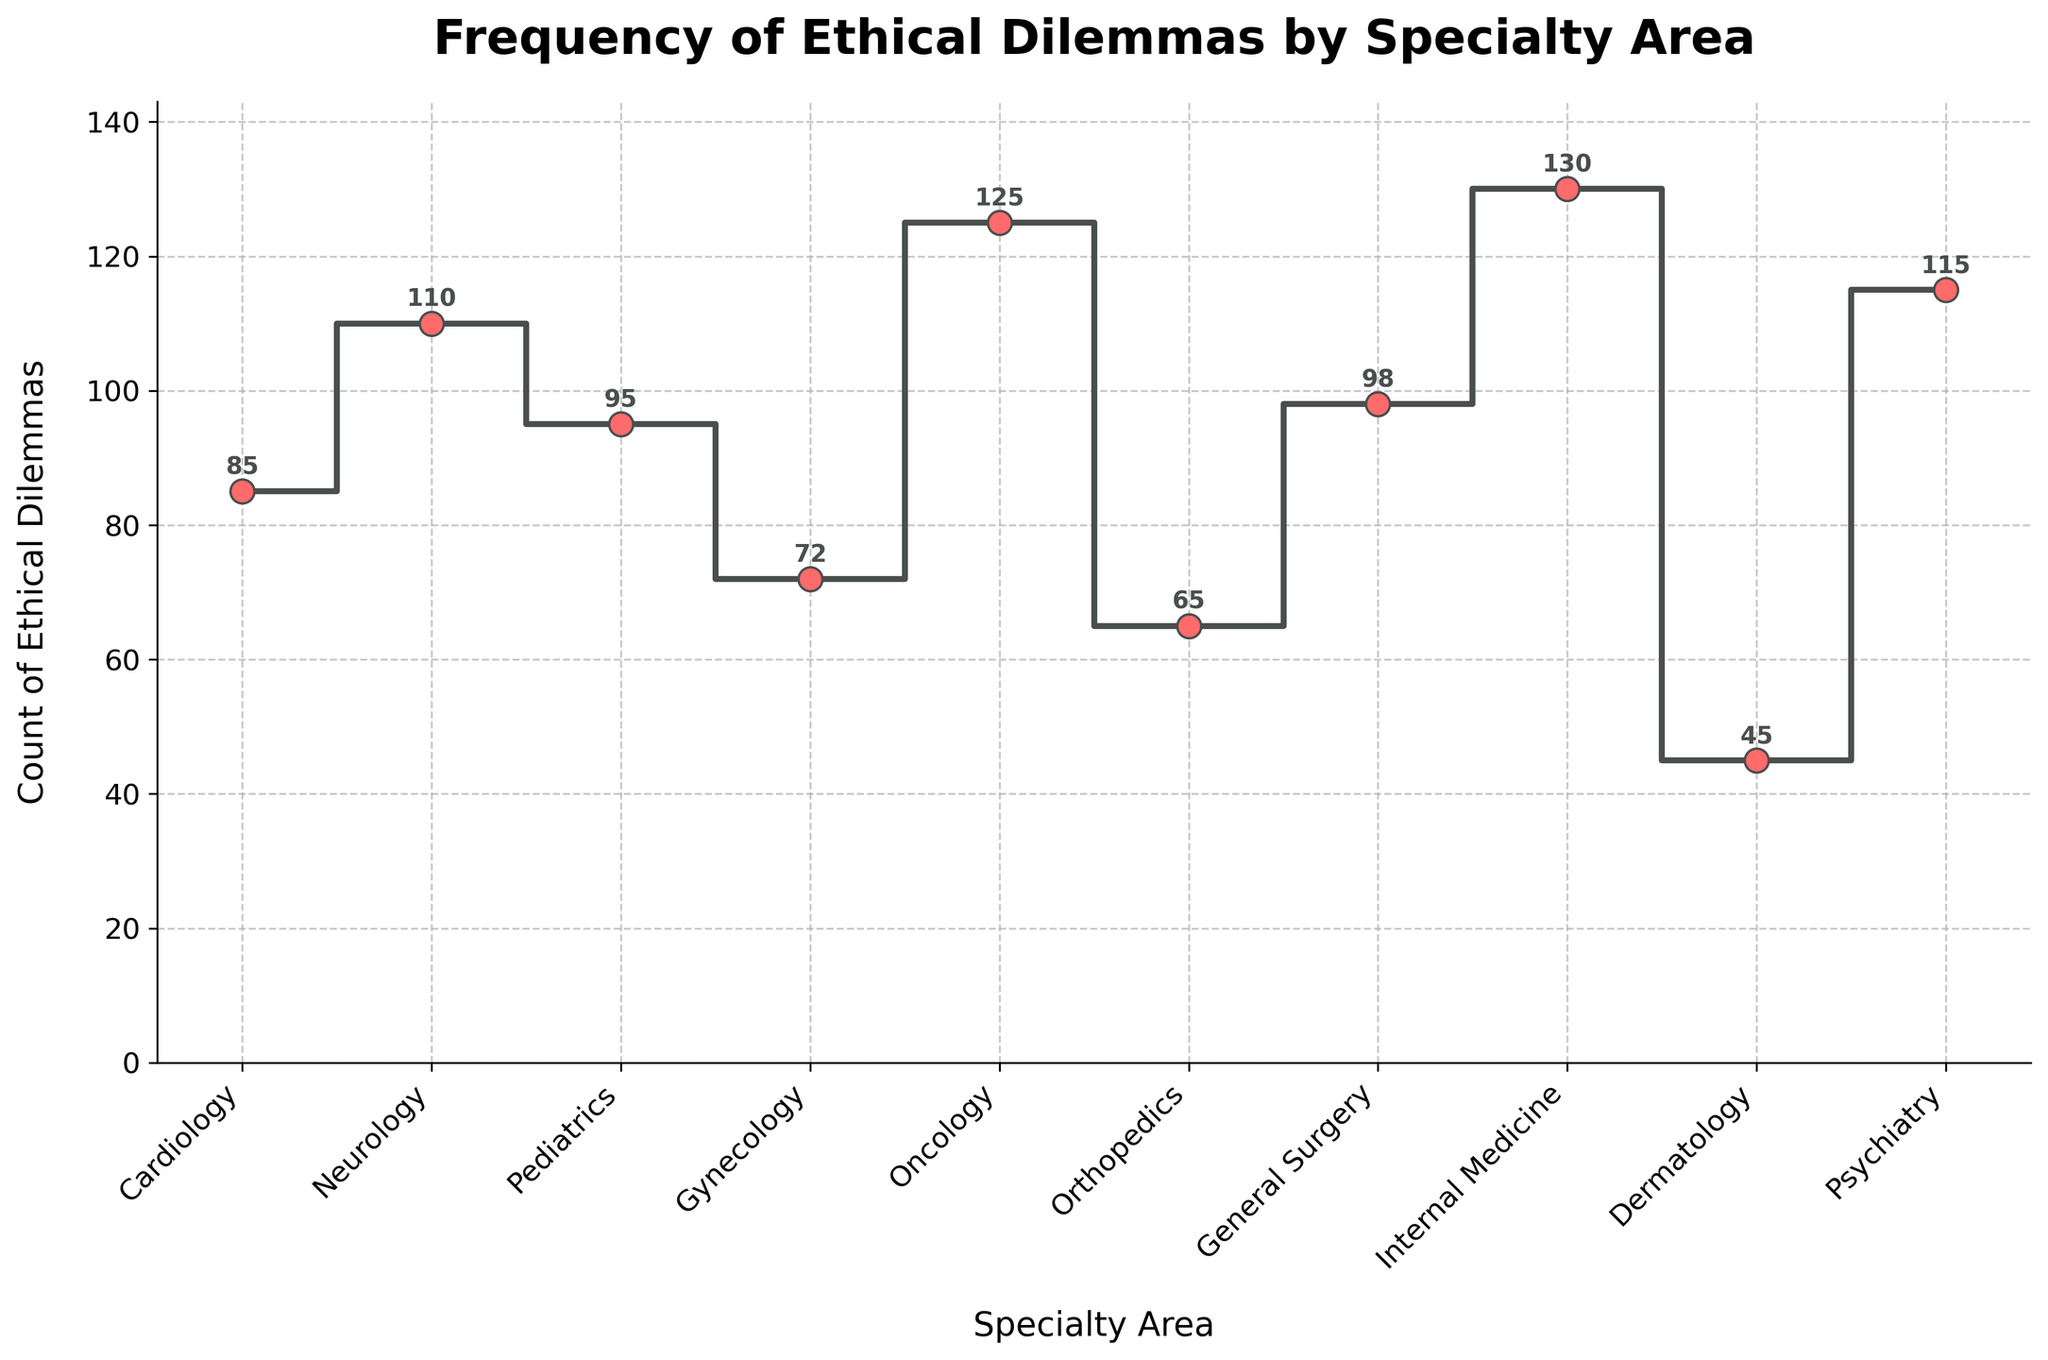What is the title of the plot? The title is usually positioned at the top of the plot and provides a brief description of what the plot represents. In this case, it says: 'Frequency of Ethical Dilemmas by Specialty Area'
Answer: Frequency of Ethical Dilemmas by Specialty Area Which specialty has the highest count of ethical dilemmas? To find the highest count, look for the tallest step in the plot. The plot shows Oncology with the highest step at 125 dilemmas.
Answer: Oncology What is the range of the counts of ethical dilemmas across all specialties? The range is the difference between the highest and lowest counts. The highest is Oncology with 125, and the lowest is Dermatology with 45. Therefore, the range is 125 - 45 = 80.
Answer: 80 How does the count of ethical dilemmas in Pediatrics compare to Gynecology? From the plot, Pediatrics has 95 dilemmas while Gynecology has 72 dilemmas. Pediatrics has 95 - 72 = 23 more dilemmas than Gynecology.
Answer: 23 more What is the combined total count of ethical dilemmas for Cardiologly and Neurology? Add the counts for Cardiology and Neurology from the plot. Cardiology has 85 and Neurology has 110 dilemmas. Their combined total is 85 + 110 = 195.
Answer: 195 Which specialties have ethical dilemma counts greater than 100? Identify the steps that are above 100 from the plot. Neurology (110), Oncology (125), Internal Medicine (130), and Psychiatry (115) all have counts above 100.
Answer: Neurology, Oncology, Internal Medicine, Psychiatry What is the average count of ethical dilemmas across all the specialties? To find the average, sum all the counts and divide by the number of specialties. The counts are: 85 + 110 + 95 + 72 + 125 + 65 + 98 + 130 + 45 + 115 = 940. There are 10 specialties, so the average is 940 / 10 = 94.
Answer: 94 How much higher is the count of ethical dilemmas in Internal Medicine compared to Dermatology? From the plot, Internal Medicine has 130 dilemmas while Dermatology has 45. So, Internal Medicine has 130 - 45 = 85 more dilemmas than Dermatology.
Answer: 85 more Which specialty has the lowest count of ethical dilemmas? Look for the shortest step in the plot. Dermatology has the lowest count with 45 dilemmas.
Answer: Dermatology 